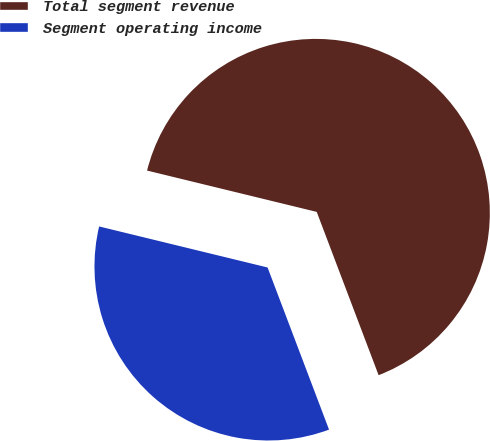<chart> <loc_0><loc_0><loc_500><loc_500><pie_chart><fcel>Total segment revenue<fcel>Segment operating income<nl><fcel>65.43%<fcel>34.57%<nl></chart> 